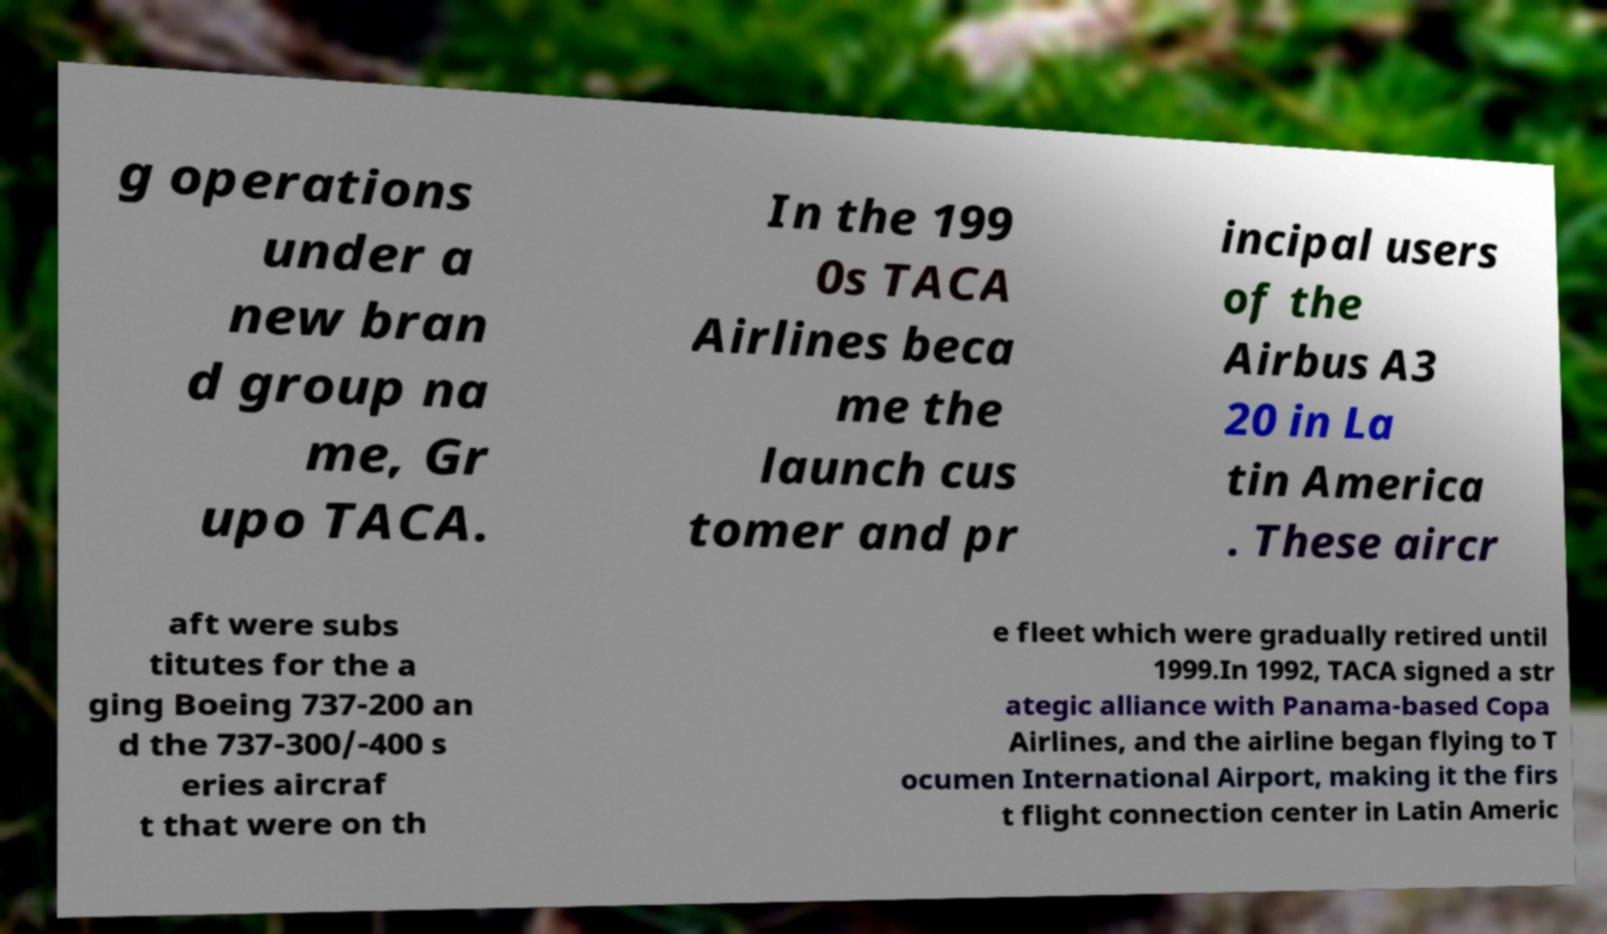Please identify and transcribe the text found in this image. g operations under a new bran d group na me, Gr upo TACA. In the 199 0s TACA Airlines beca me the launch cus tomer and pr incipal users of the Airbus A3 20 in La tin America . These aircr aft were subs titutes for the a ging Boeing 737-200 an d the 737-300/-400 s eries aircraf t that were on th e fleet which were gradually retired until 1999.In 1992, TACA signed a str ategic alliance with Panama-based Copa Airlines, and the airline began flying to T ocumen International Airport, making it the firs t flight connection center in Latin Americ 